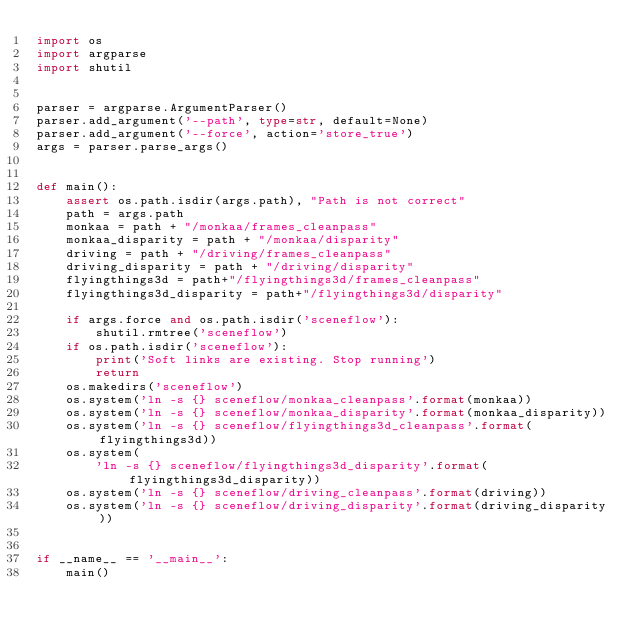Convert code to text. <code><loc_0><loc_0><loc_500><loc_500><_Python_>import os
import argparse
import shutil


parser = argparse.ArgumentParser()
parser.add_argument('--path', type=str, default=None)
parser.add_argument('--force', action='store_true')
args = parser.parse_args()


def main():
    assert os.path.isdir(args.path), "Path is not correct"
    path = args.path
    monkaa = path + "/monkaa/frames_cleanpass"
    monkaa_disparity = path + "/monkaa/disparity"
    driving = path + "/driving/frames_cleanpass"
    driving_disparity = path + "/driving/disparity"
    flyingthings3d = path+"/flyingthings3d/frames_cleanpass"
    flyingthings3d_disparity = path+"/flyingthings3d/disparity"

    if args.force and os.path.isdir('sceneflow'):
        shutil.rmtree('sceneflow')
    if os.path.isdir('sceneflow'):
        print('Soft links are existing. Stop running')
        return
    os.makedirs('sceneflow')
    os.system('ln -s {} sceneflow/monkaa_cleanpass'.format(monkaa))
    os.system('ln -s {} sceneflow/monkaa_disparity'.format(monkaa_disparity))
    os.system('ln -s {} sceneflow/flyingthings3d_cleanpass'.format(flyingthings3d))
    os.system(
        'ln -s {} sceneflow/flyingthings3d_disparity'.format(flyingthings3d_disparity))
    os.system('ln -s {} sceneflow/driving_cleanpass'.format(driving))
    os.system('ln -s {} sceneflow/driving_disparity'.format(driving_disparity))


if __name__ == '__main__':
    main()</code> 